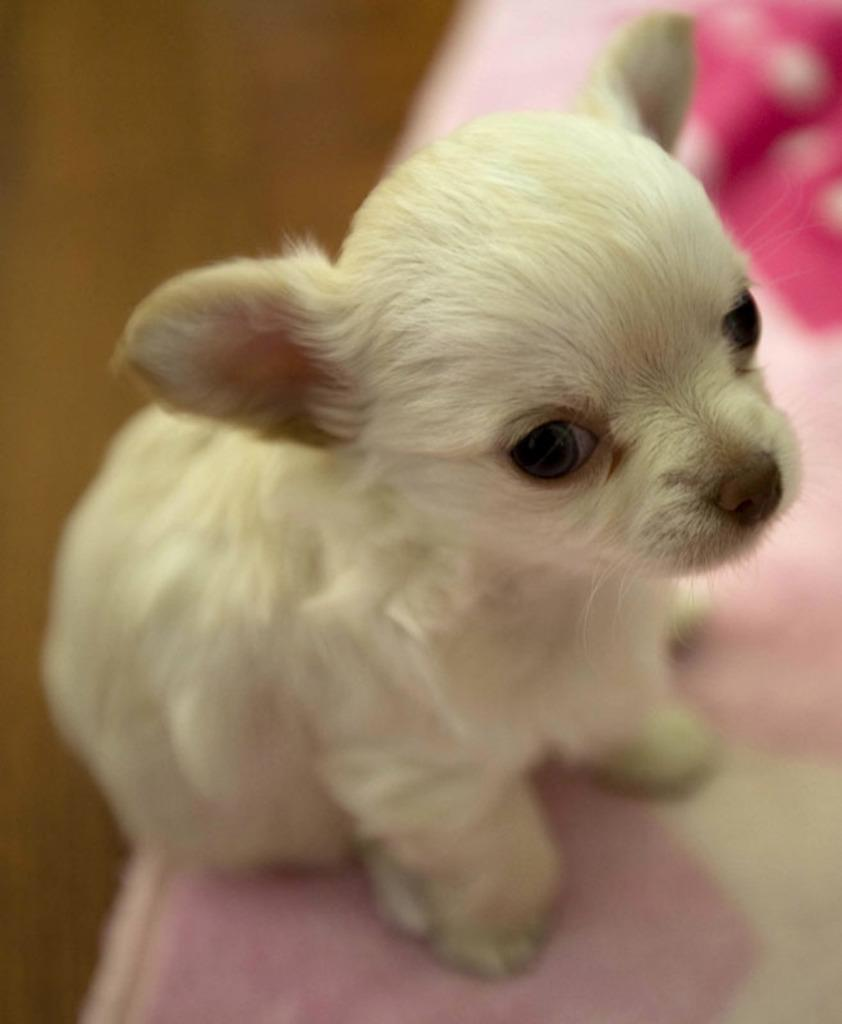What animal is present in the image? There is a dog in the image. Where is the dog located? The dog is on a table. What key is the dog using to open the door in the image? There is no key or door present in the image; it only features a dog on a table. 